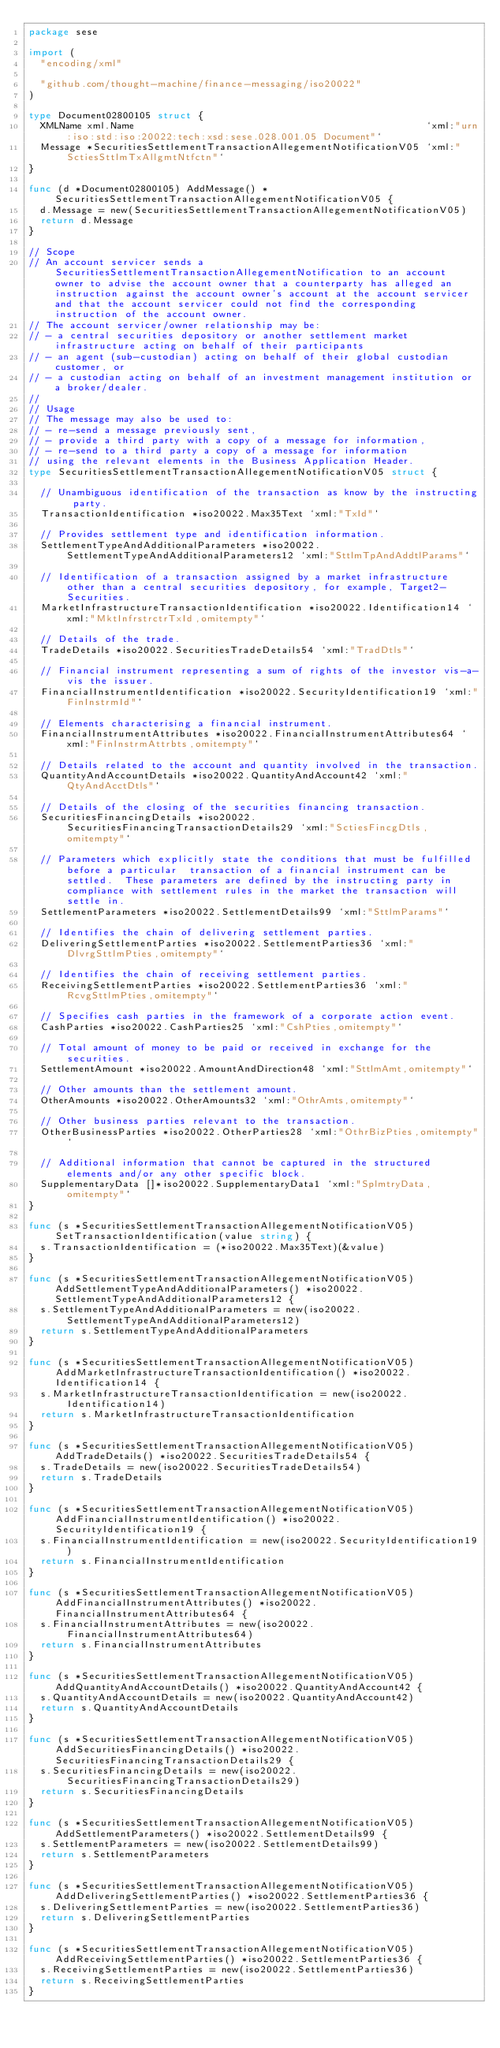Convert code to text. <code><loc_0><loc_0><loc_500><loc_500><_Go_>package sese

import (
	"encoding/xml"

	"github.com/thought-machine/finance-messaging/iso20022"
)

type Document02800105 struct {
	XMLName xml.Name                                                  `xml:"urn:iso:std:iso:20022:tech:xsd:sese.028.001.05 Document"`
	Message *SecuritiesSettlementTransactionAllegementNotificationV05 `xml:"SctiesSttlmTxAllgmtNtfctn"`
}

func (d *Document02800105) AddMessage() *SecuritiesSettlementTransactionAllegementNotificationV05 {
	d.Message = new(SecuritiesSettlementTransactionAllegementNotificationV05)
	return d.Message
}

// Scope
// An account servicer sends a SecuritiesSettlementTransactionAllegementNotification to an account owner to advise the account owner that a counterparty has alleged an instruction against the account owner's account at the account servicer and that the account servicer could not find the corresponding instruction of the account owner.
// The account servicer/owner relationship may be:
// - a central securities depository or another settlement market infrastructure acting on behalf of their participants
// - an agent (sub-custodian) acting on behalf of their global custodian customer, or
// - a custodian acting on behalf of an investment management institution or a broker/dealer.
//
// Usage
// The message may also be used to:
// - re-send a message previously sent,
// - provide a third party with a copy of a message for information,
// - re-send to a third party a copy of a message for information
// using the relevant elements in the Business Application Header.
type SecuritiesSettlementTransactionAllegementNotificationV05 struct {

	// Unambiguous identification of the transaction as know by the instructing party.
	TransactionIdentification *iso20022.Max35Text `xml:"TxId"`

	// Provides settlement type and identification information.
	SettlementTypeAndAdditionalParameters *iso20022.SettlementTypeAndAdditionalParameters12 `xml:"SttlmTpAndAddtlParams"`

	// Identification of a transaction assigned by a market infrastructure other than a central securities depository, for example, Target2-Securities.
	MarketInfrastructureTransactionIdentification *iso20022.Identification14 `xml:"MktInfrstrctrTxId,omitempty"`

	// Details of the trade.
	TradeDetails *iso20022.SecuritiesTradeDetails54 `xml:"TradDtls"`

	// Financial instrument representing a sum of rights of the investor vis-a-vis the issuer.
	FinancialInstrumentIdentification *iso20022.SecurityIdentification19 `xml:"FinInstrmId"`

	// Elements characterising a financial instrument.
	FinancialInstrumentAttributes *iso20022.FinancialInstrumentAttributes64 `xml:"FinInstrmAttrbts,omitempty"`

	// Details related to the account and quantity involved in the transaction.
	QuantityAndAccountDetails *iso20022.QuantityAndAccount42 `xml:"QtyAndAcctDtls"`

	// Details of the closing of the securities financing transaction.
	SecuritiesFinancingDetails *iso20022.SecuritiesFinancingTransactionDetails29 `xml:"SctiesFincgDtls,omitempty"`

	// Parameters which explicitly state the conditions that must be fulfilled before a particular  transaction of a financial instrument can be settled.  These parameters are defined by the instructing party in compliance with settlement rules in the market the transaction will settle in.
	SettlementParameters *iso20022.SettlementDetails99 `xml:"SttlmParams"`

	// Identifies the chain of delivering settlement parties.
	DeliveringSettlementParties *iso20022.SettlementParties36 `xml:"DlvrgSttlmPties,omitempty"`

	// Identifies the chain of receiving settlement parties.
	ReceivingSettlementParties *iso20022.SettlementParties36 `xml:"RcvgSttlmPties,omitempty"`

	// Specifies cash parties in the framework of a corporate action event.
	CashParties *iso20022.CashParties25 `xml:"CshPties,omitempty"`

	// Total amount of money to be paid or received in exchange for the securities.
	SettlementAmount *iso20022.AmountAndDirection48 `xml:"SttlmAmt,omitempty"`

	// Other amounts than the settlement amount.
	OtherAmounts *iso20022.OtherAmounts32 `xml:"OthrAmts,omitempty"`

	// Other business parties relevant to the transaction.
	OtherBusinessParties *iso20022.OtherParties28 `xml:"OthrBizPties,omitempty"`

	// Additional information that cannot be captured in the structured elements and/or any other specific block.
	SupplementaryData []*iso20022.SupplementaryData1 `xml:"SplmtryData,omitempty"`
}

func (s *SecuritiesSettlementTransactionAllegementNotificationV05) SetTransactionIdentification(value string) {
	s.TransactionIdentification = (*iso20022.Max35Text)(&value)
}

func (s *SecuritiesSettlementTransactionAllegementNotificationV05) AddSettlementTypeAndAdditionalParameters() *iso20022.SettlementTypeAndAdditionalParameters12 {
	s.SettlementTypeAndAdditionalParameters = new(iso20022.SettlementTypeAndAdditionalParameters12)
	return s.SettlementTypeAndAdditionalParameters
}

func (s *SecuritiesSettlementTransactionAllegementNotificationV05) AddMarketInfrastructureTransactionIdentification() *iso20022.Identification14 {
	s.MarketInfrastructureTransactionIdentification = new(iso20022.Identification14)
	return s.MarketInfrastructureTransactionIdentification
}

func (s *SecuritiesSettlementTransactionAllegementNotificationV05) AddTradeDetails() *iso20022.SecuritiesTradeDetails54 {
	s.TradeDetails = new(iso20022.SecuritiesTradeDetails54)
	return s.TradeDetails
}

func (s *SecuritiesSettlementTransactionAllegementNotificationV05) AddFinancialInstrumentIdentification() *iso20022.SecurityIdentification19 {
	s.FinancialInstrumentIdentification = new(iso20022.SecurityIdentification19)
	return s.FinancialInstrumentIdentification
}

func (s *SecuritiesSettlementTransactionAllegementNotificationV05) AddFinancialInstrumentAttributes() *iso20022.FinancialInstrumentAttributes64 {
	s.FinancialInstrumentAttributes = new(iso20022.FinancialInstrumentAttributes64)
	return s.FinancialInstrumentAttributes
}

func (s *SecuritiesSettlementTransactionAllegementNotificationV05) AddQuantityAndAccountDetails() *iso20022.QuantityAndAccount42 {
	s.QuantityAndAccountDetails = new(iso20022.QuantityAndAccount42)
	return s.QuantityAndAccountDetails
}

func (s *SecuritiesSettlementTransactionAllegementNotificationV05) AddSecuritiesFinancingDetails() *iso20022.SecuritiesFinancingTransactionDetails29 {
	s.SecuritiesFinancingDetails = new(iso20022.SecuritiesFinancingTransactionDetails29)
	return s.SecuritiesFinancingDetails
}

func (s *SecuritiesSettlementTransactionAllegementNotificationV05) AddSettlementParameters() *iso20022.SettlementDetails99 {
	s.SettlementParameters = new(iso20022.SettlementDetails99)
	return s.SettlementParameters
}

func (s *SecuritiesSettlementTransactionAllegementNotificationV05) AddDeliveringSettlementParties() *iso20022.SettlementParties36 {
	s.DeliveringSettlementParties = new(iso20022.SettlementParties36)
	return s.DeliveringSettlementParties
}

func (s *SecuritiesSettlementTransactionAllegementNotificationV05) AddReceivingSettlementParties() *iso20022.SettlementParties36 {
	s.ReceivingSettlementParties = new(iso20022.SettlementParties36)
	return s.ReceivingSettlementParties
}
</code> 